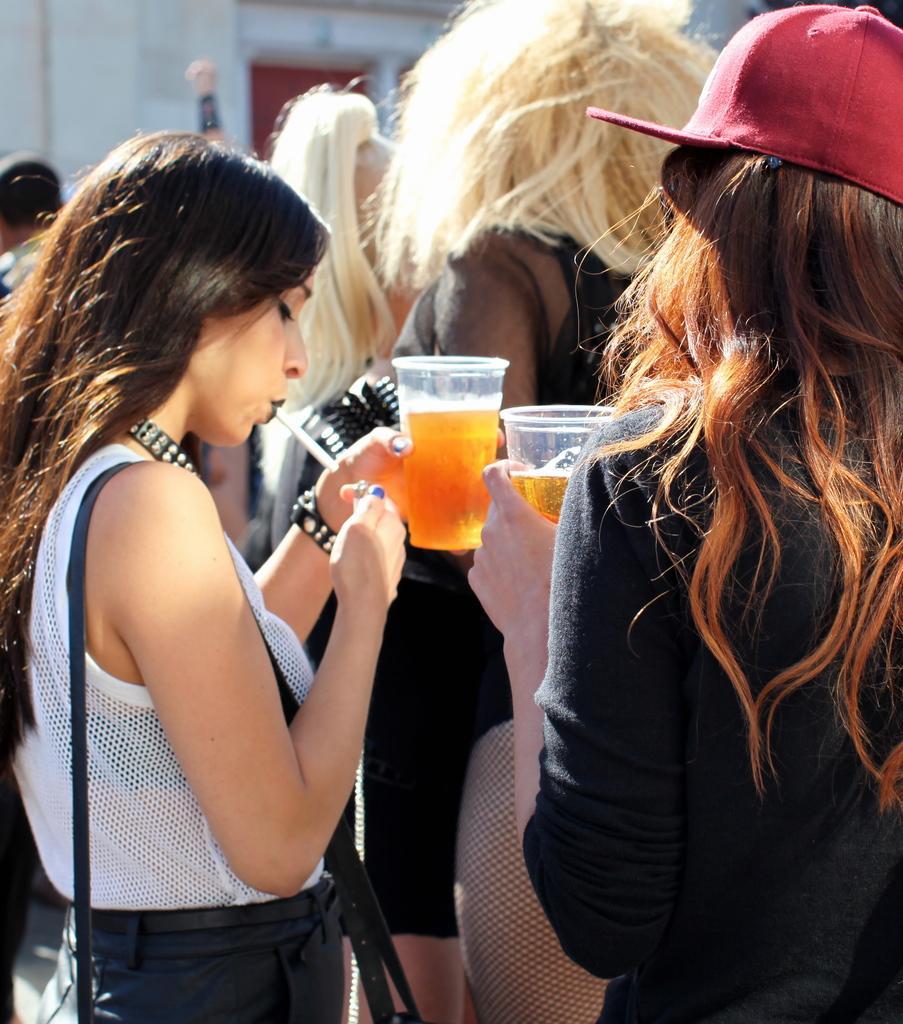In one or two sentences, can you explain what this image depicts? This image is clicked outside. To the left, the women wearing white shirt is lighting a cigarette. To the woman wearing black dress is holding a glass of beer. In the background, there is a building. 